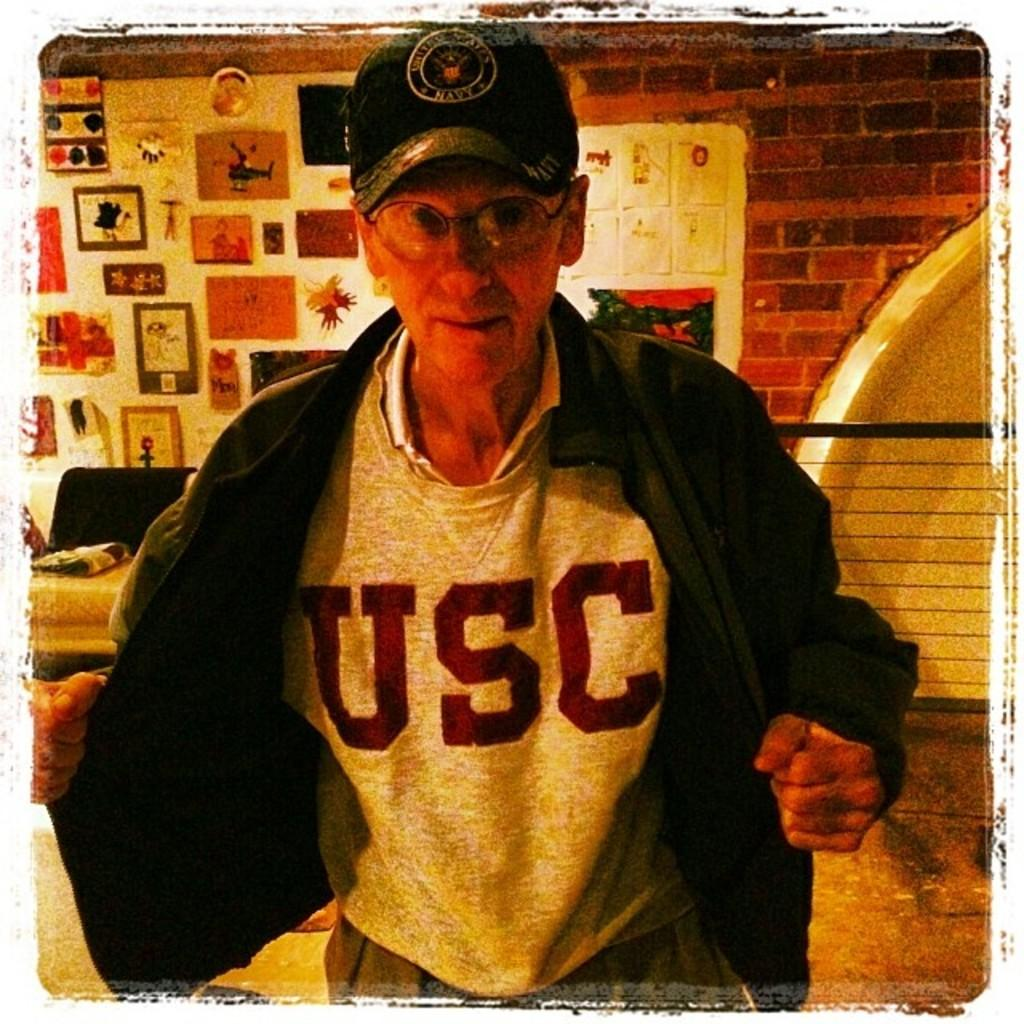<image>
Describe the image concisely. An old man wearing a USC sweatshirt and a US Navy hat. 